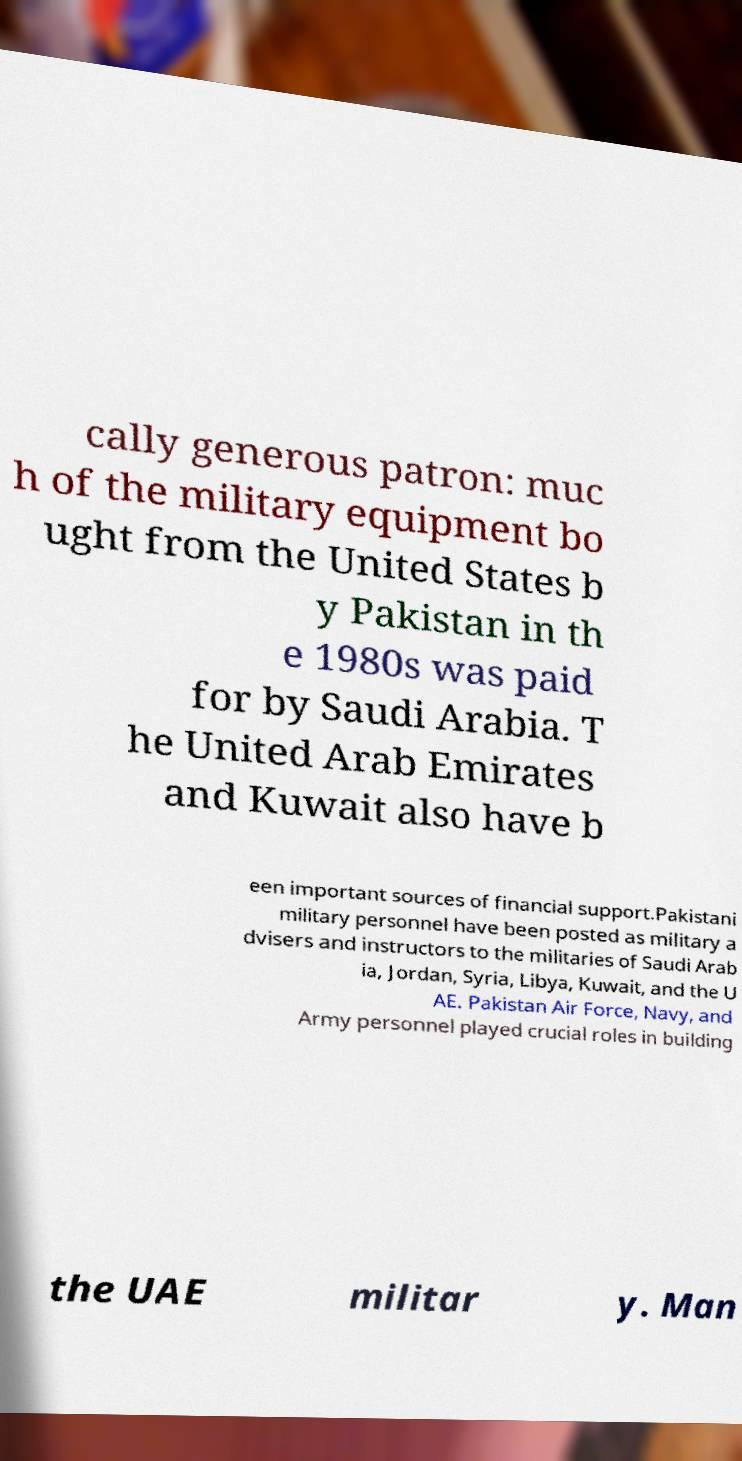What messages or text are displayed in this image? I need them in a readable, typed format. cally generous patron: muc h of the military equipment bo ught from the United States b y Pakistan in th e 1980s was paid for by Saudi Arabia. T he United Arab Emirates and Kuwait also have b een important sources of financial support.Pakistani military personnel have been posted as military a dvisers and instructors to the militaries of Saudi Arab ia, Jordan, Syria, Libya, Kuwait, and the U AE. Pakistan Air Force, Navy, and Army personnel played crucial roles in building the UAE militar y. Man 